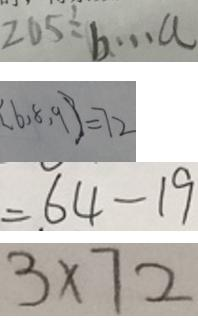<formula> <loc_0><loc_0><loc_500><loc_500>2 0 5 \div b \cdots a 
 [ 6 , 8 , 9 ] = 7 2 
 = 6 4 - 1 9 
 3 \times 7 2</formula> 